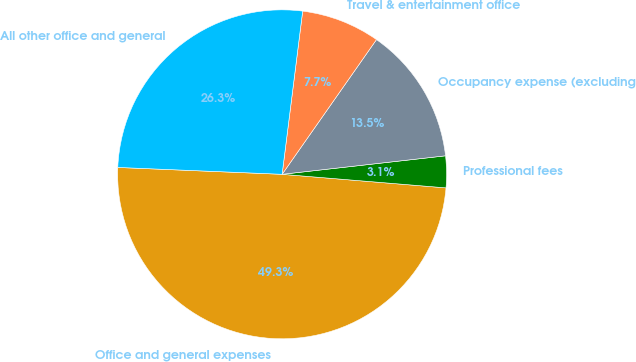Convert chart. <chart><loc_0><loc_0><loc_500><loc_500><pie_chart><fcel>Office and general expenses<fcel>Professional fees<fcel>Occupancy expense (excluding<fcel>Travel & entertainment office<fcel>All other office and general<nl><fcel>49.35%<fcel>3.11%<fcel>13.48%<fcel>7.73%<fcel>26.33%<nl></chart> 